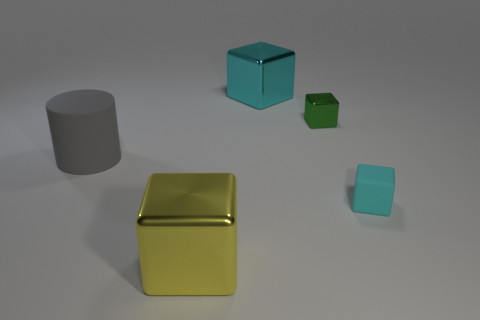What is the shape of the object that is behind the cyan rubber thing and left of the large cyan metallic block?
Make the answer very short. Cylinder. There is a metallic cube that is the same color as the tiny matte object; what is its size?
Provide a succinct answer. Large. There is a matte object that is on the right side of the small shiny thing; what is its size?
Keep it short and to the point. Small. What material is the cyan block behind the cyan block in front of the matte cylinder?
Give a very brief answer. Metal. How many big yellow cubes are to the left of the cyan thing that is in front of the big metal cube that is behind the yellow shiny block?
Make the answer very short. 1. Does the large yellow object that is in front of the large cyan block have the same material as the cyan thing that is in front of the big gray thing?
Offer a very short reply. No. What material is the large cube that is the same color as the tiny matte block?
Provide a short and direct response. Metal. How many other big metal objects are the same shape as the yellow metallic object?
Make the answer very short. 1. Are there more cyan blocks in front of the gray matte cylinder than purple metal things?
Provide a short and direct response. Yes. The rubber object on the left side of the big thing that is to the right of the metallic thing that is in front of the green cube is what shape?
Your answer should be compact. Cylinder. 